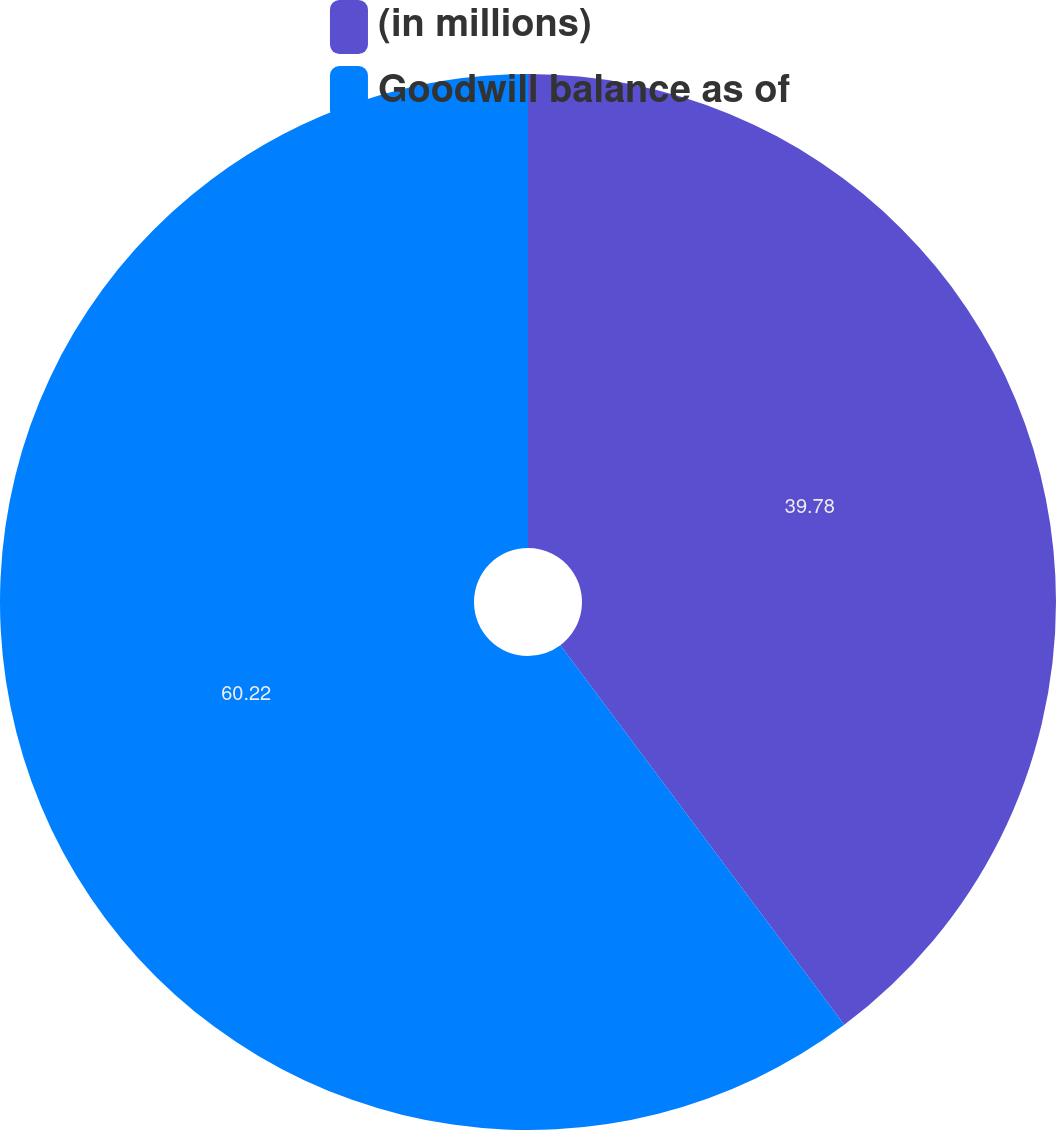Convert chart. <chart><loc_0><loc_0><loc_500><loc_500><pie_chart><fcel>(in millions)<fcel>Goodwill balance as of<nl><fcel>39.78%<fcel>60.22%<nl></chart> 